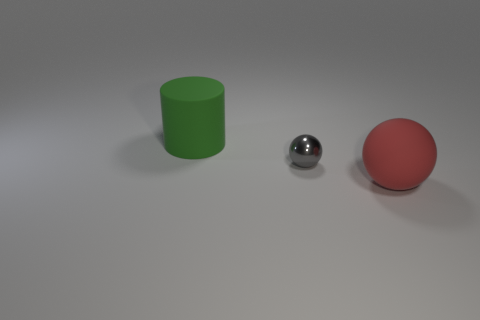Is there anything else that is the same size as the gray thing?
Your answer should be compact. No. There is another object that is the same shape as the red object; what color is it?
Make the answer very short. Gray. Is there anything else that has the same color as the big matte ball?
Offer a very short reply. No. How many metal things are either big cylinders or tiny yellow blocks?
Your answer should be very brief. 0. Is the color of the big matte cylinder the same as the matte ball?
Your response must be concise. No. Are there more things that are behind the rubber sphere than purple rubber blocks?
Offer a terse response. Yes. How many other objects are there of the same material as the small object?
Your answer should be very brief. 0. What number of small things are cylinders or cyan rubber balls?
Make the answer very short. 0. Do the big red ball and the green object have the same material?
Provide a short and direct response. Yes. There is a large object in front of the green rubber cylinder; what number of red rubber spheres are behind it?
Offer a very short reply. 0. 